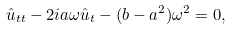<formula> <loc_0><loc_0><loc_500><loc_500>\hat { u } _ { t t } - 2 i a \omega \hat { u } _ { t } - ( b - a ^ { 2 } ) \omega ^ { 2 } = 0 ,</formula> 